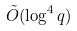<formula> <loc_0><loc_0><loc_500><loc_500>\tilde { O } ( \log ^ { 4 } q )</formula> 